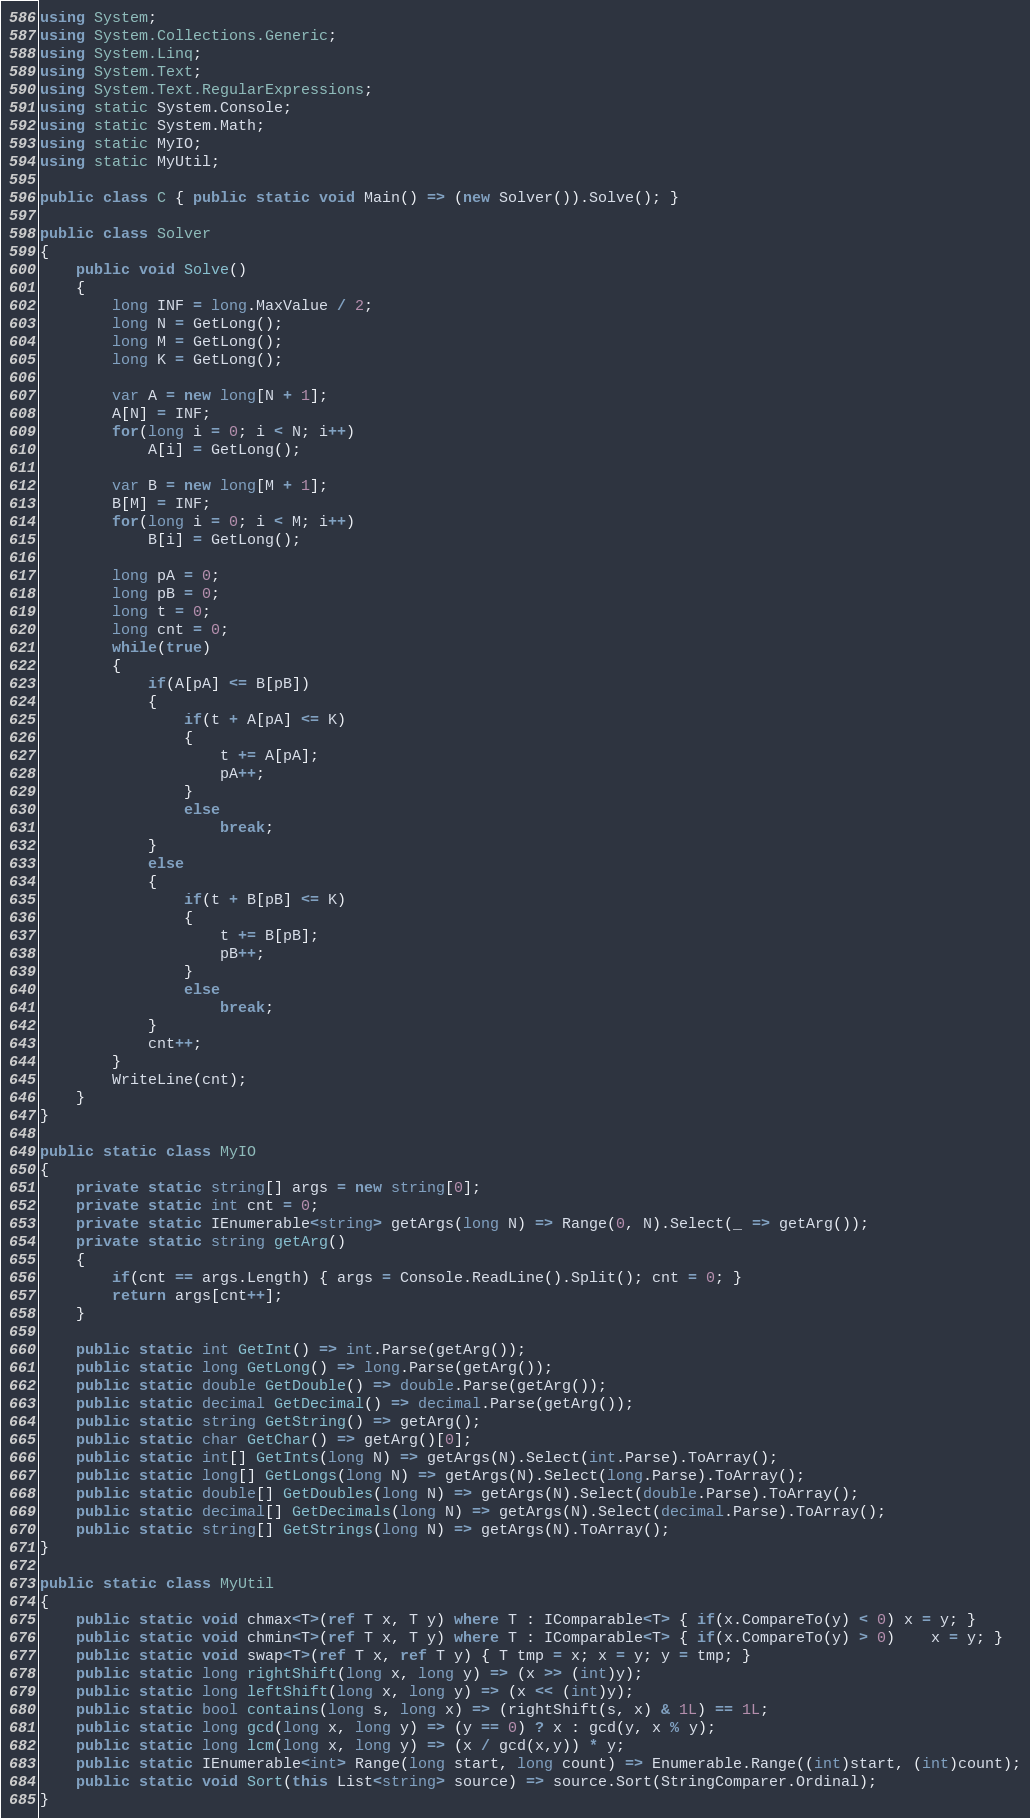Convert code to text. <code><loc_0><loc_0><loc_500><loc_500><_C#_>using System;
using System.Collections.Generic;
using System.Linq;
using System.Text;
using System.Text.RegularExpressions;
using static System.Console;
using static System.Math;
using static MyIO;
using static MyUtil;

public class C { public static void Main() => (new Solver()).Solve(); }

public class Solver
{
	public void Solve()
	{
		long INF = long.MaxValue / 2;
		long N = GetLong();
		long M = GetLong();
		long K = GetLong();

		var A = new long[N + 1];
		A[N] = INF;
		for(long i = 0; i < N; i++)
			A[i] = GetLong();

		var B = new long[M + 1];
		B[M] = INF;
		for(long i = 0; i < M; i++)
			B[i] = GetLong();

		long pA = 0;
		long pB = 0;
		long t = 0;
		long cnt = 0;
		while(true)
		{
			if(A[pA] <= B[pB])
			{
				if(t + A[pA] <= K)
				{
					t += A[pA];
					pA++;
				}
				else
					break;
			}
			else
			{
				if(t + B[pB] <= K)
				{
					t += B[pB];
					pB++;
				}
				else
					break;
			}
			cnt++;
		}
		WriteLine(cnt);
	}
}

public static class MyIO
{
	private static string[] args = new string[0];
	private static int cnt = 0;
	private static IEnumerable<string> getArgs(long N) => Range(0, N).Select(_ => getArg());
	private static string getArg()
	{
		if(cnt == args.Length) { args = Console.ReadLine().Split(); cnt = 0; }
		return args[cnt++];
	}

	public static int GetInt() => int.Parse(getArg());
	public static long GetLong() => long.Parse(getArg());
	public static double GetDouble() => double.Parse(getArg());
	public static decimal GetDecimal() => decimal.Parse(getArg());
	public static string GetString() => getArg();
	public static char GetChar() => getArg()[0];
	public static int[] GetInts(long N) => getArgs(N).Select(int.Parse).ToArray();
	public static long[] GetLongs(long N) => getArgs(N).Select(long.Parse).ToArray();
	public static double[] GetDoubles(long N) => getArgs(N).Select(double.Parse).ToArray();
	public static decimal[] GetDecimals(long N) => getArgs(N).Select(decimal.Parse).ToArray();
	public static string[] GetStrings(long N) => getArgs(N).ToArray();
}

public static class MyUtil
{
	public static void chmax<T>(ref T x, T y) where T : IComparable<T> { if(x.CompareTo(y) < 0) x = y; }
	public static void chmin<T>(ref T x, T y) where T : IComparable<T> { if(x.CompareTo(y) > 0)	x = y; }
	public static void swap<T>(ref T x, ref T y) { T tmp = x; x = y; y = tmp; }
	public static long rightShift(long x, long y) => (x >> (int)y);
	public static long leftShift(long x, long y) => (x << (int)y);
	public static bool contains(long s, long x) => (rightShift(s, x) & 1L) == 1L;
	public static long gcd(long x, long y) => (y == 0) ? x : gcd(y, x % y);
	public static long lcm(long x, long y) => (x / gcd(x,y)) * y;	
	public static IEnumerable<int> Range(long start, long count) => Enumerable.Range((int)start, (int)count);
	public static void Sort(this List<string> source) => source.Sort(StringComparer.Ordinal);
}
</code> 